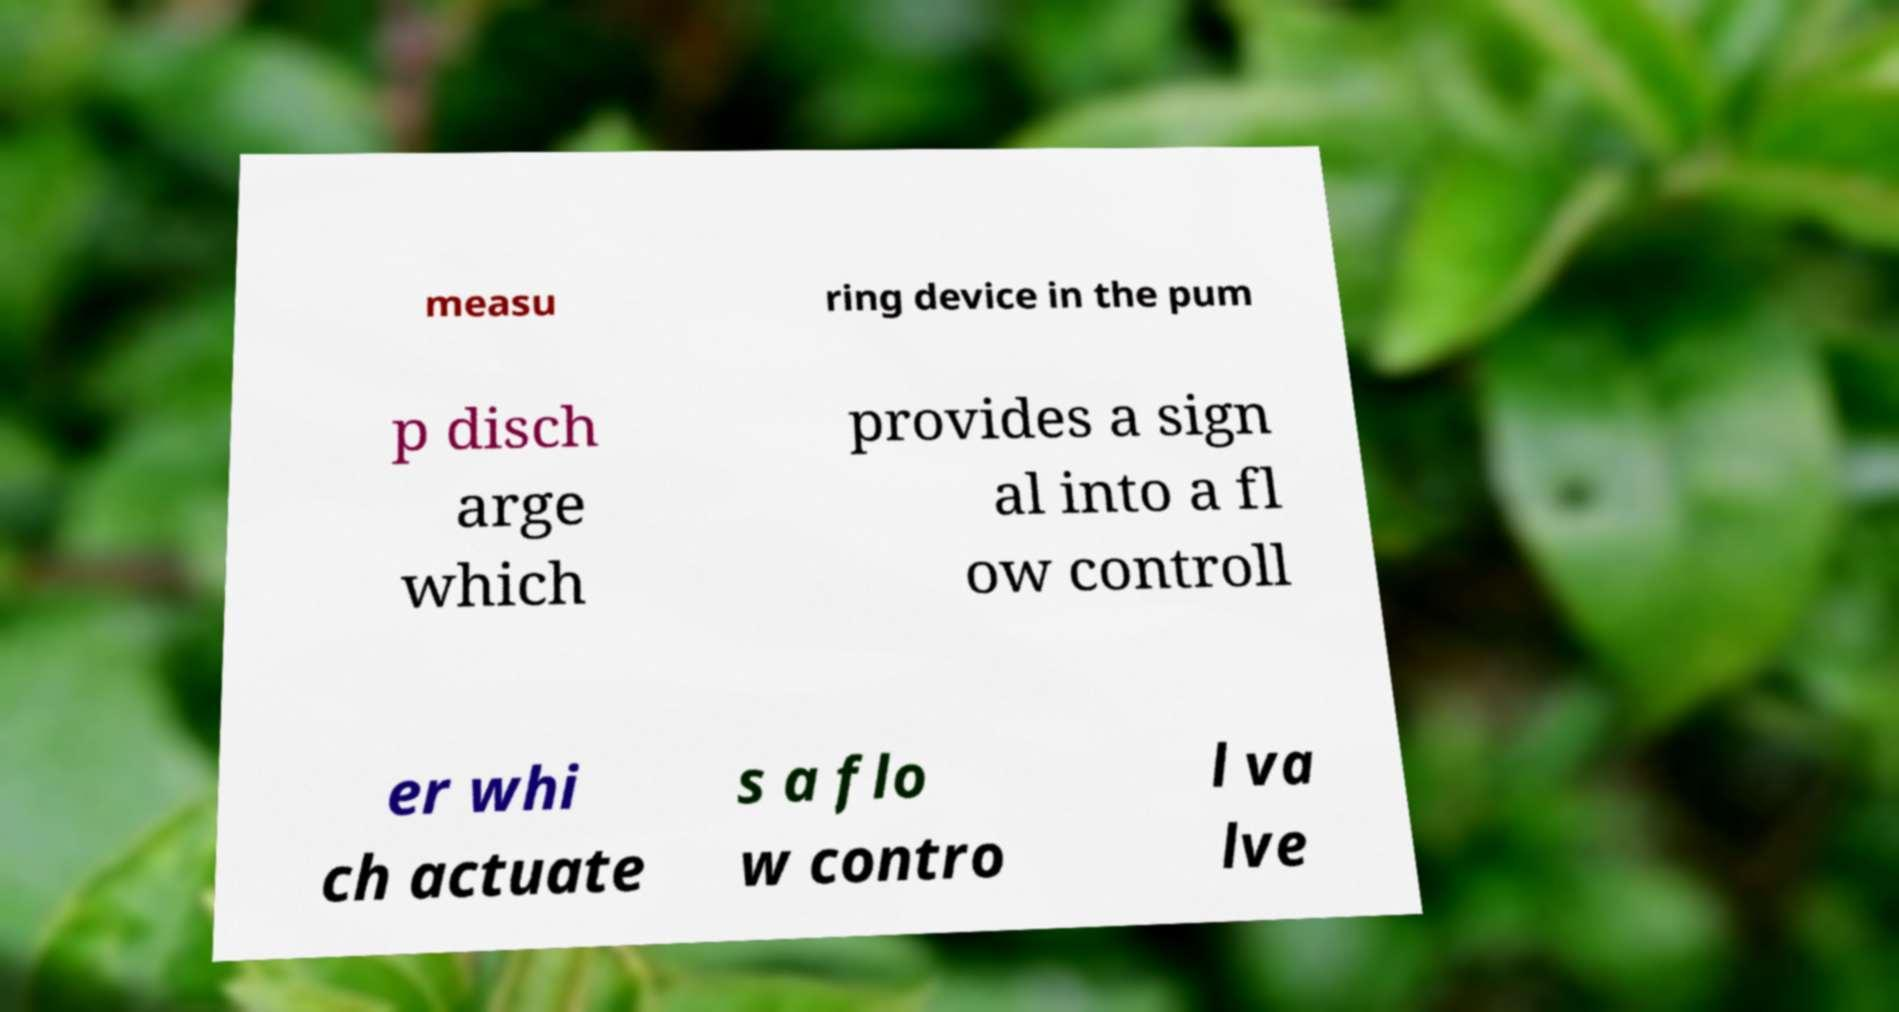Please identify and transcribe the text found in this image. measu ring device in the pum p disch arge which provides a sign al into a fl ow controll er whi ch actuate s a flo w contro l va lve 